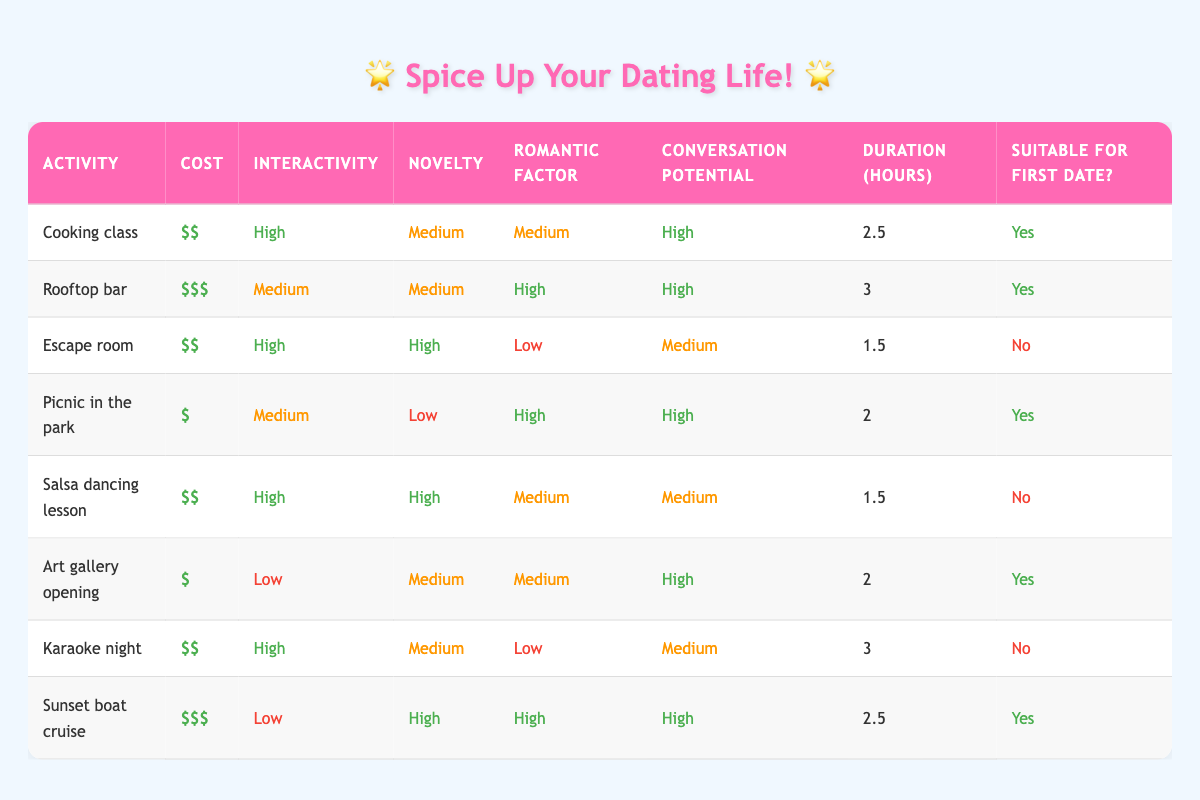What is the activity with the highest romantic factor? Looking at the table, the activity with the highest romantic factor is the rooftop bar, which has a romantic factor classified as high.
Answer: Rooftop bar How many date options are suitable for a first date? Filtering the table for activities that are suitable for a first date, we find cooking class, rooftop bar, picnic in the park, art gallery opening, and sunset boat cruise, which totals five options.
Answer: 5 What is the average duration of the activities suitable for a first date? The suitable activities and their durations are: cooking class (2.5), rooftop bar (3.0), picnic in the park (2.0), art gallery opening (2.0), and sunset boat cruise (2.5). The total duration is 2.5 + 3 + 2 + 2 + 2.5 = 12. Total activities = 5. Average = 12/5 = 2.4 hours.
Answer: 2.4 hours Is the escape room a suitable option for a first date? The table clearly states that the escape room is classified as not suitable for a first date.
Answer: No Which activity has the lowest cost and is also suitable for a first date? Reviewing the options in the table, the picnic in the park is the lowest cost option at $ and is also marked as suitable for a first date.
Answer: Picnic in the park What is the activity with the longest duration that is not suitable for a first date? Looking at the activities in the table, karaoke night lasts for 3 hours and is marked as not suitable for a first date, making it the longest such option.
Answer: Karaoke night How many options have high interactivity? By scanning the table for activities with high interactivity, we identify cooking class, escape room, salsa dancing lesson, and karaoke night. This sums up to four options.
Answer: 4 Which activity has the highest novelty factor and costs less than $100? The sunset boat cruise has the highest novelty factor classified as high and costs $$$, which is below $100 (assuming that is the reference cost). Alternatively, escape room has the highest novelty factor and costs $$$.
Answer: Escape room 